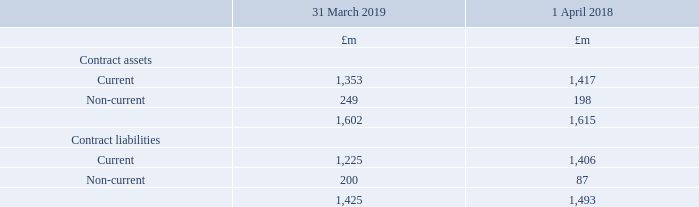6. Revenue continued
Contract assets and liabilities recognised at 31 March 2019 are as follows:
£1,216m of the contract liability recognised at 1 April 2018 was recognised as revenue during the year. Impairment losses of £36m were recognised on contract assets during the year. Other than business-as-usual movements there were no significant changes in contract asset and liability balances during the year.
How much contract liability was recognised at 1 April 2018? £1,216m of the contract liability recognised at 1 april 2018. How much Impairment losses was recognised at 2018? Impairment losses of £36m were recognised on contract assets during the year. What was the current contract assets at 2019?
Answer scale should be: million. 1,353. What is the change in Contract assets: Current from 31 March 2019 to 1 April 2018?
Answer scale should be: million. 1,353-1,417
Answer: -64. What is the change in Contract assets: Non-Current from 31 March 2019 to 1 April 2018?
Answer scale should be: million. 249-198
Answer: 51. What is the change in Contract liabilities: Current from 31 March 2019 to 1 April 2018?
Answer scale should be: million. 1,225-1,406
Answer: -181. 